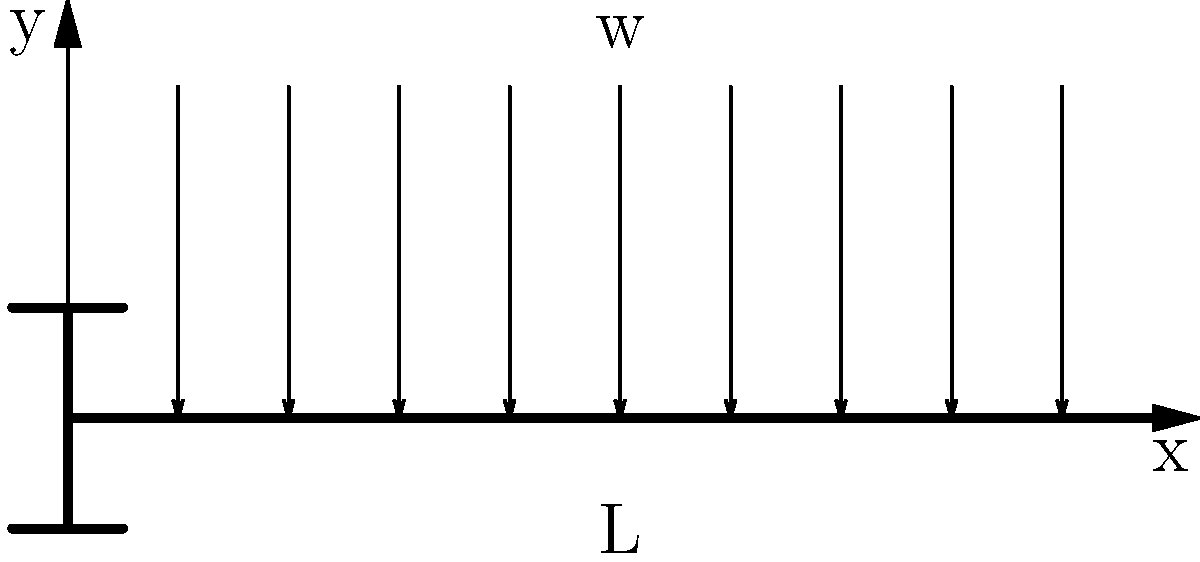A cantilever beam of length L is subjected to a uniformly distributed load w per unit length. As a market research analyst gathering data on engineering solutions, you need to determine the maximum deflection of the beam. Given that the beam is made of steel with Young's modulus E = 200 GPa and has a rectangular cross-section with moment of inertia I = 1.5 × 10^-6 m^4, what is the expression for the maximum deflection at the free end of the beam? To find the maximum deflection of a cantilever beam under a uniformly distributed load, we follow these steps:

1. Recall the general equation for the deflection of a beam:
   $$\frac{d^2y}{dx^2} = \frac{M(x)}{EI}$$
   where M(x) is the bending moment, E is Young's modulus, and I is the moment of inertia.

2. For a cantilever beam with a uniformly distributed load w, the bending moment at any point x is:
   $$M(x) = \frac{w}{2}(L^2 - x^2)$$

3. Substituting this into the general equation:
   $$\frac{d^2y}{dx^2} = \frac{w}{2EI}(L^2 - x^2)$$

4. Integrate twice to get the deflection equation:
   $$\frac{dy}{dx} = \frac{w}{2EI}(L^2x - \frac{x^3}{3}) + C_1$$
   $$y = \frac{w}{2EI}(\frac{L^2x^2}{2} - \frac{x^4}{12}) + C_1x + C_2$$

5. Apply boundary conditions:
   At x = 0 (fixed end): y = 0 and dy/dx = 0
   This gives C_1 = C_2 = 0

6. The maximum deflection occurs at the free end (x = L):
   $$y_{max} = \frac{wL^4}{8EI}$$

This expression gives the maximum deflection at the free end of the cantilever beam under a uniformly distributed load.
Answer: $y_{max} = \frac{wL^4}{8EI}$ 